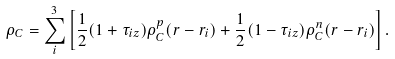Convert formula to latex. <formula><loc_0><loc_0><loc_500><loc_500>\rho _ { C } = \sum ^ { 3 } _ { i } \left [ \frac { 1 } { 2 } ( 1 + \tau _ { i z } ) \rho _ { C } ^ { p } ( { r } - { r } _ { i } ) + \frac { 1 } { 2 } ( 1 - \tau _ { i z } ) \rho _ { C } ^ { n } ( { r } - { r } _ { i } ) \right ] .</formula> 